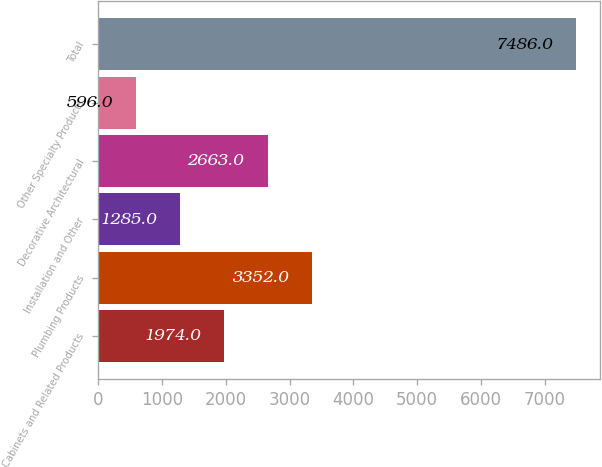Convert chart. <chart><loc_0><loc_0><loc_500><loc_500><bar_chart><fcel>Cabinets and Related Products<fcel>Plumbing Products<fcel>Installation and Other<fcel>Decorative Architectural<fcel>Other Specialty Products<fcel>Total<nl><fcel>1974<fcel>3352<fcel>1285<fcel>2663<fcel>596<fcel>7486<nl></chart> 